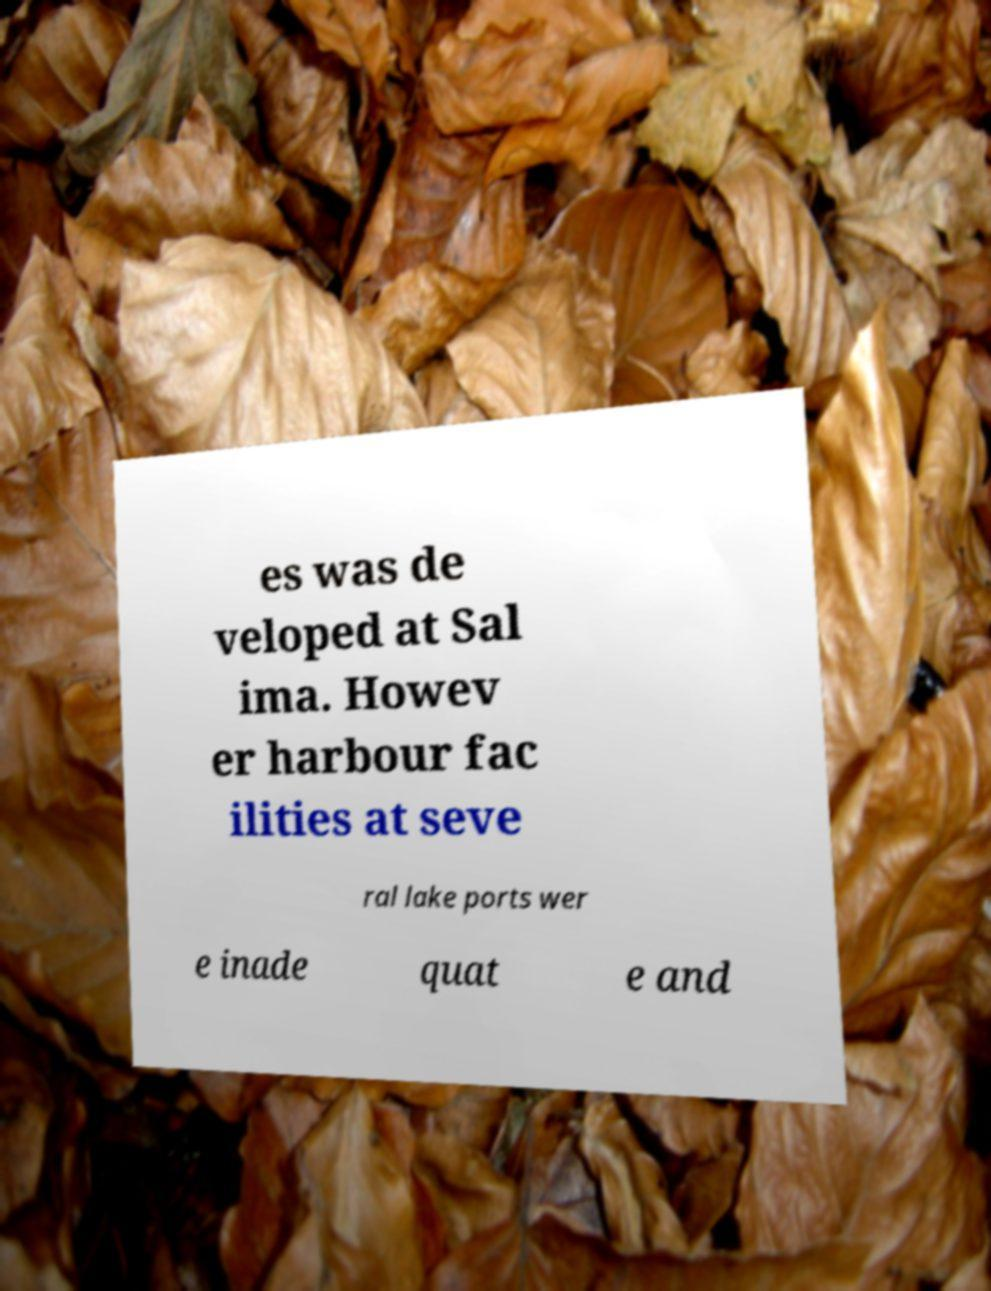Please read and relay the text visible in this image. What does it say? es was de veloped at Sal ima. Howev er harbour fac ilities at seve ral lake ports wer e inade quat e and 